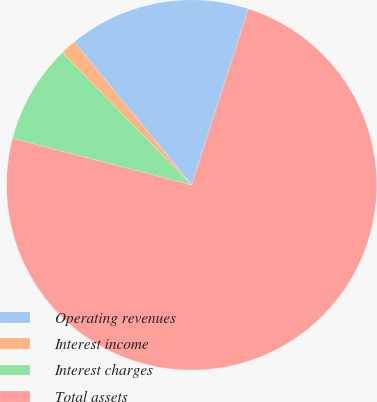Convert chart. <chart><loc_0><loc_0><loc_500><loc_500><pie_chart><fcel>Operating revenues<fcel>Interest income<fcel>Interest charges<fcel>Total assets<nl><fcel>15.91%<fcel>1.37%<fcel>8.64%<fcel>74.09%<nl></chart> 